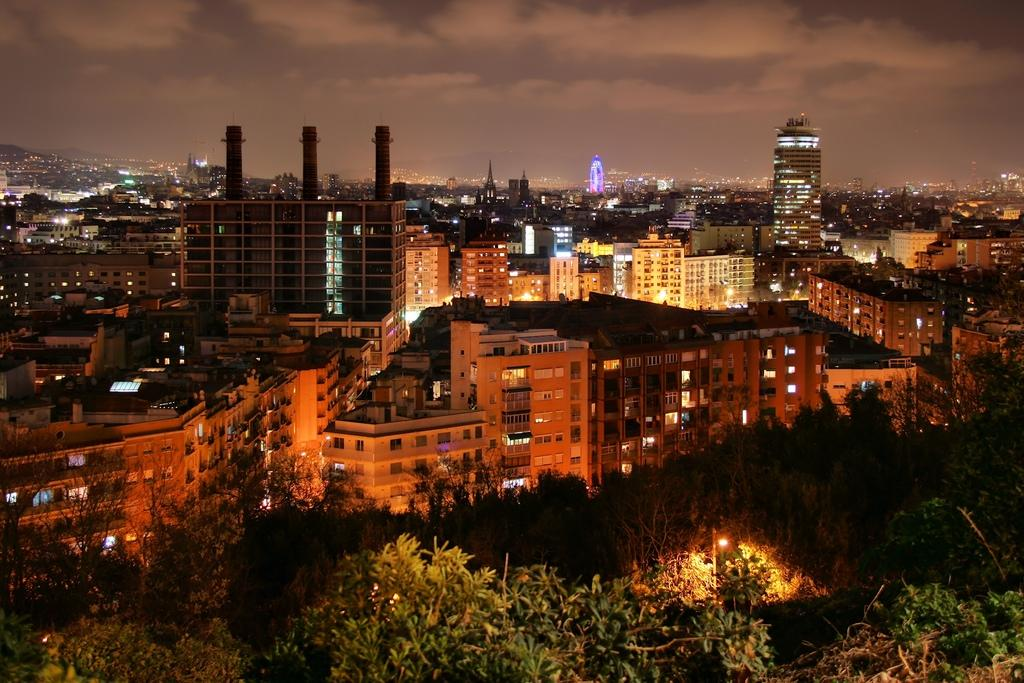What is located in the center of the image? There are buildings in the center of the image. What can be seen at the bottom of the image? There are trees at the bottom of the image. What is visible at the top of the image? The sky is visible at the top of the image. What can be observed in the sky? Clouds are present in the sky. What type of wrist is visible in the image? There is no wrist present in the image. What system is responsible for the movement of the clouds in the image? The image does not show any clouds moving, and therefore, there is no system responsible for their movement in the image. 